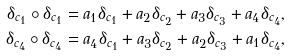<formula> <loc_0><loc_0><loc_500><loc_500>\delta _ { c _ { 1 } } \circ \delta _ { c _ { 1 } } & = a _ { 1 } \delta _ { c _ { 1 } } + a _ { 2 } \delta _ { c _ { 2 } } + a _ { 3 } \delta _ { c _ { 3 } } + a _ { 4 } \delta _ { c _ { 4 } } , \\ \delta _ { c _ { 4 } } \circ \delta _ { c _ { 4 } } & = a _ { 4 } \delta _ { c _ { 1 } } + a _ { 3 } \delta _ { c _ { 2 } } + a _ { 2 } \delta _ { c _ { 3 } } + a _ { 1 } \delta _ { c _ { 4 } } ,</formula> 